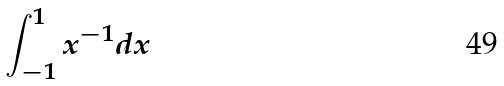Convert formula to latex. <formula><loc_0><loc_0><loc_500><loc_500>\int _ { - 1 } ^ { 1 } x ^ { - 1 } d x</formula> 